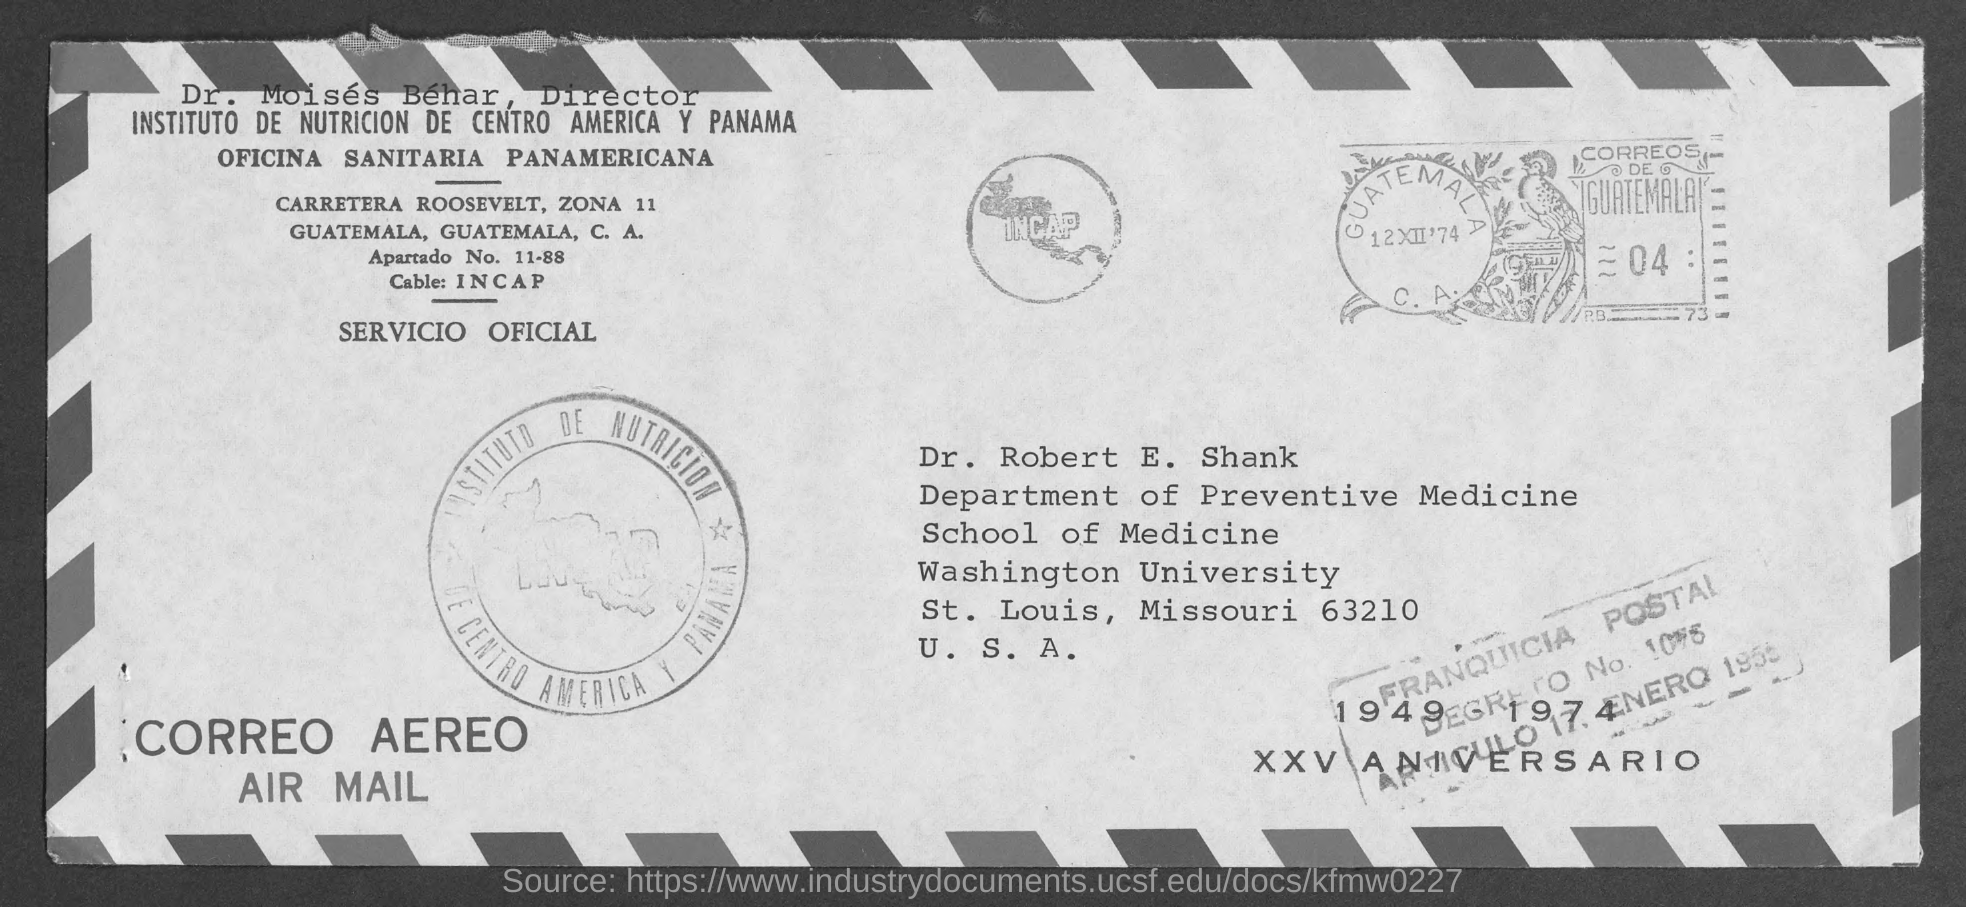To Whom is this mail addressed to?
Offer a very short reply. Dr. Robert E. Shank. 